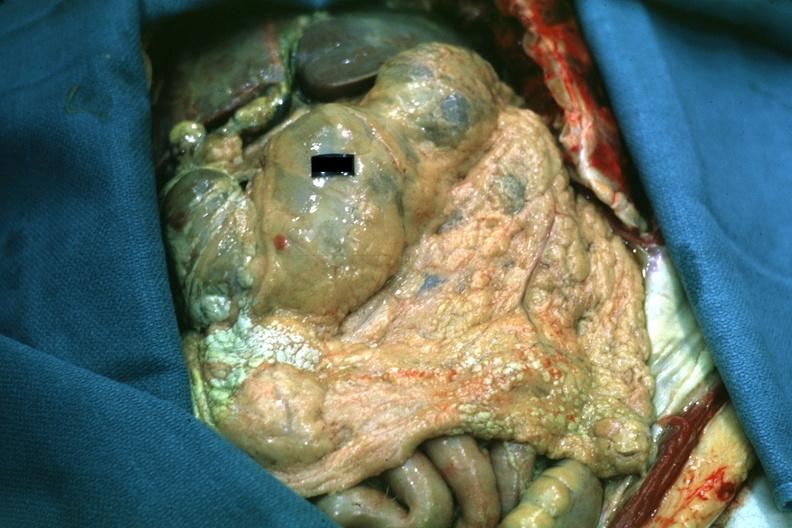where is this area in the body?
Answer the question using a single word or phrase. Abdomen 